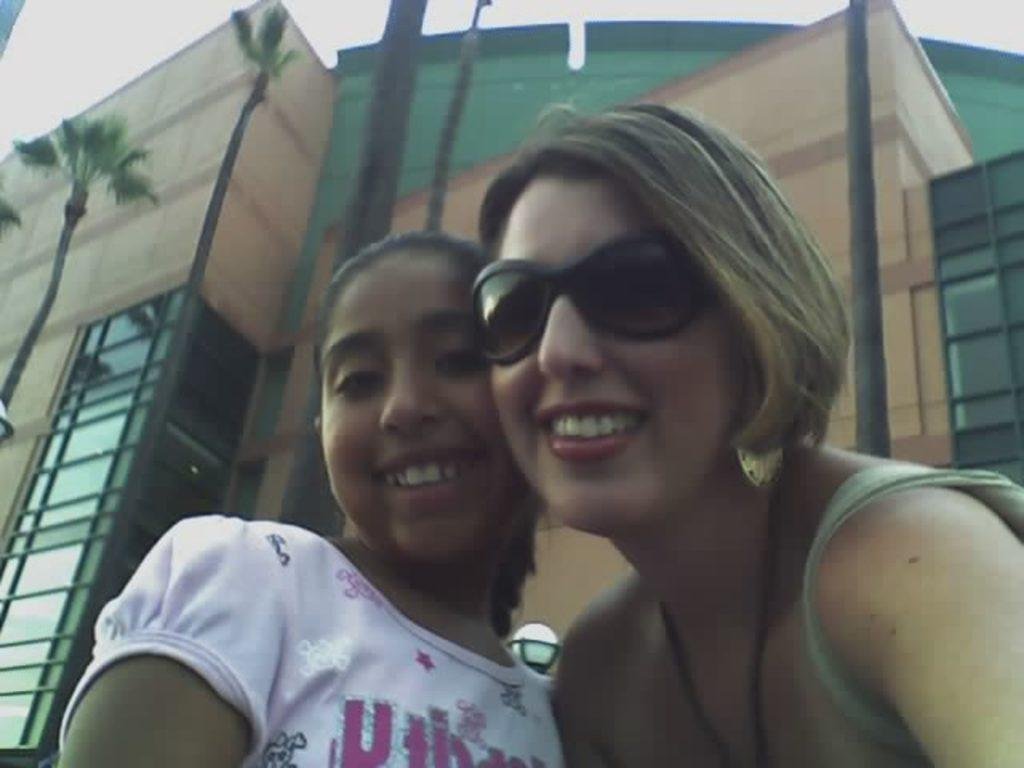How many people are present in the image? There are two ladies in the image. What can be seen in the background of the image? There are buildings and trees in the background of the image. What type of operation is being performed on the trees in the image? There is no operation being performed on the trees in the image; they are simply visible in the background. 